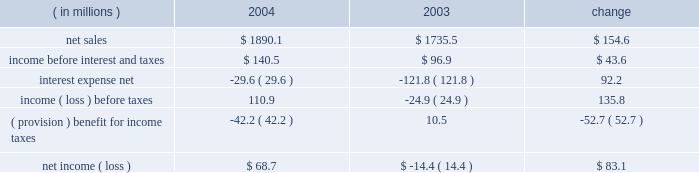Instruments at fair value and to recognize the effective and ineffective portions of the cash flow hedges .
( 2 ) for the year ended december 31 , 2000 , earnings available to common stockholders includes reductions of $ 2371 of preferred stock dividends and $ 16266 for the redemption of pca 2019s 123 20448% ( 20448 % ) preferred stock .
( 3 ) on october 13 , 2003 , pca announced its intention to begin paying a quarterly cash dividend of $ 0.15 per share , or $ 0.60 per share annually , on its common stock .
The first quarterly dividend of $ 0.15 per share was paid on january 15 , 2004 to shareholders of record as of december 15 , 2003 .
Pca did not declare any dividends on its common stock in 2000 - 2002 .
( 4 ) total long-term obligations include long-term debt , short-term debt and the current maturities of long-term debt .
Item 7 .
Management 2019s discussion and analysis of financial condition and results of operations the following discussion of historical results of operations and financial condition should be read in conjunction with the audited financial statements and the notes thereto which appear elsewhere in this report .
Overview on april 12 , 1999 , pca acquired the containerboard and corrugated products business of pactiv corporation ( the 201cgroup 201d ) , formerly known as tenneco packaging inc. , a wholly owned subsidiary of tenneco , inc .
The group operated prior to april 12 , 1999 as a division of pactiv , and not as a separate , stand-alone entity .
From its formation in january 1999 and through the closing of the acquisition on april 12 , 1999 , pca did not have any significant operations .
The april 12 , 1999 acquisition was accounted for using historical values for the contributed assets .
Purchase accounting was not applied because , under the applicable accounting guidance , a change of control was deemed not to have occurred as a result of the participating veto rights held by pactiv after the closing of the transactions under the terms of the stockholders agreement entered into in connection with the transactions .
Results of operations year ended december 31 , 2004 compared to year ended december 31 , 2003 the historical results of operations of pca for the years ended december , 31 2004 and 2003 are set forth the below : for the year ended december 31 , ( in millions ) 2004 2003 change .

What was the percentage change in net sales between 2003 and 2004? 
Computations: (154.6 / 1735.5)
Answer: 0.08908. 